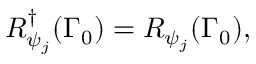<formula> <loc_0><loc_0><loc_500><loc_500>R _ { \psi _ { j } } ^ { \dagger } ( \Gamma _ { 0 } ) = R _ { \psi _ { j } } ( \Gamma _ { 0 } ) ,</formula> 